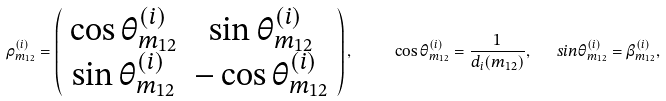<formula> <loc_0><loc_0><loc_500><loc_500>\rho ^ { ( i ) } _ { m _ { 1 2 } } = \left ( \begin{array} { c c } \cos \theta ^ { ( i ) } _ { m _ { 1 2 } } & \sin \theta ^ { ( i ) } _ { m _ { 1 2 } } \\ \sin \theta ^ { ( i ) } _ { m _ { 1 2 } } & - \cos \theta ^ { ( i ) } _ { m _ { 1 2 } } \end{array} \right ) , \quad \ \cos \theta ^ { ( i ) } _ { m _ { 1 2 } } = \frac { 1 } { d _ { i } ( m _ { 1 2 } ) } , \ \ \ sin \theta ^ { ( i ) } _ { m _ { 1 2 } } = \beta ^ { ( i ) } _ { m _ { 1 2 } } ,</formula> 